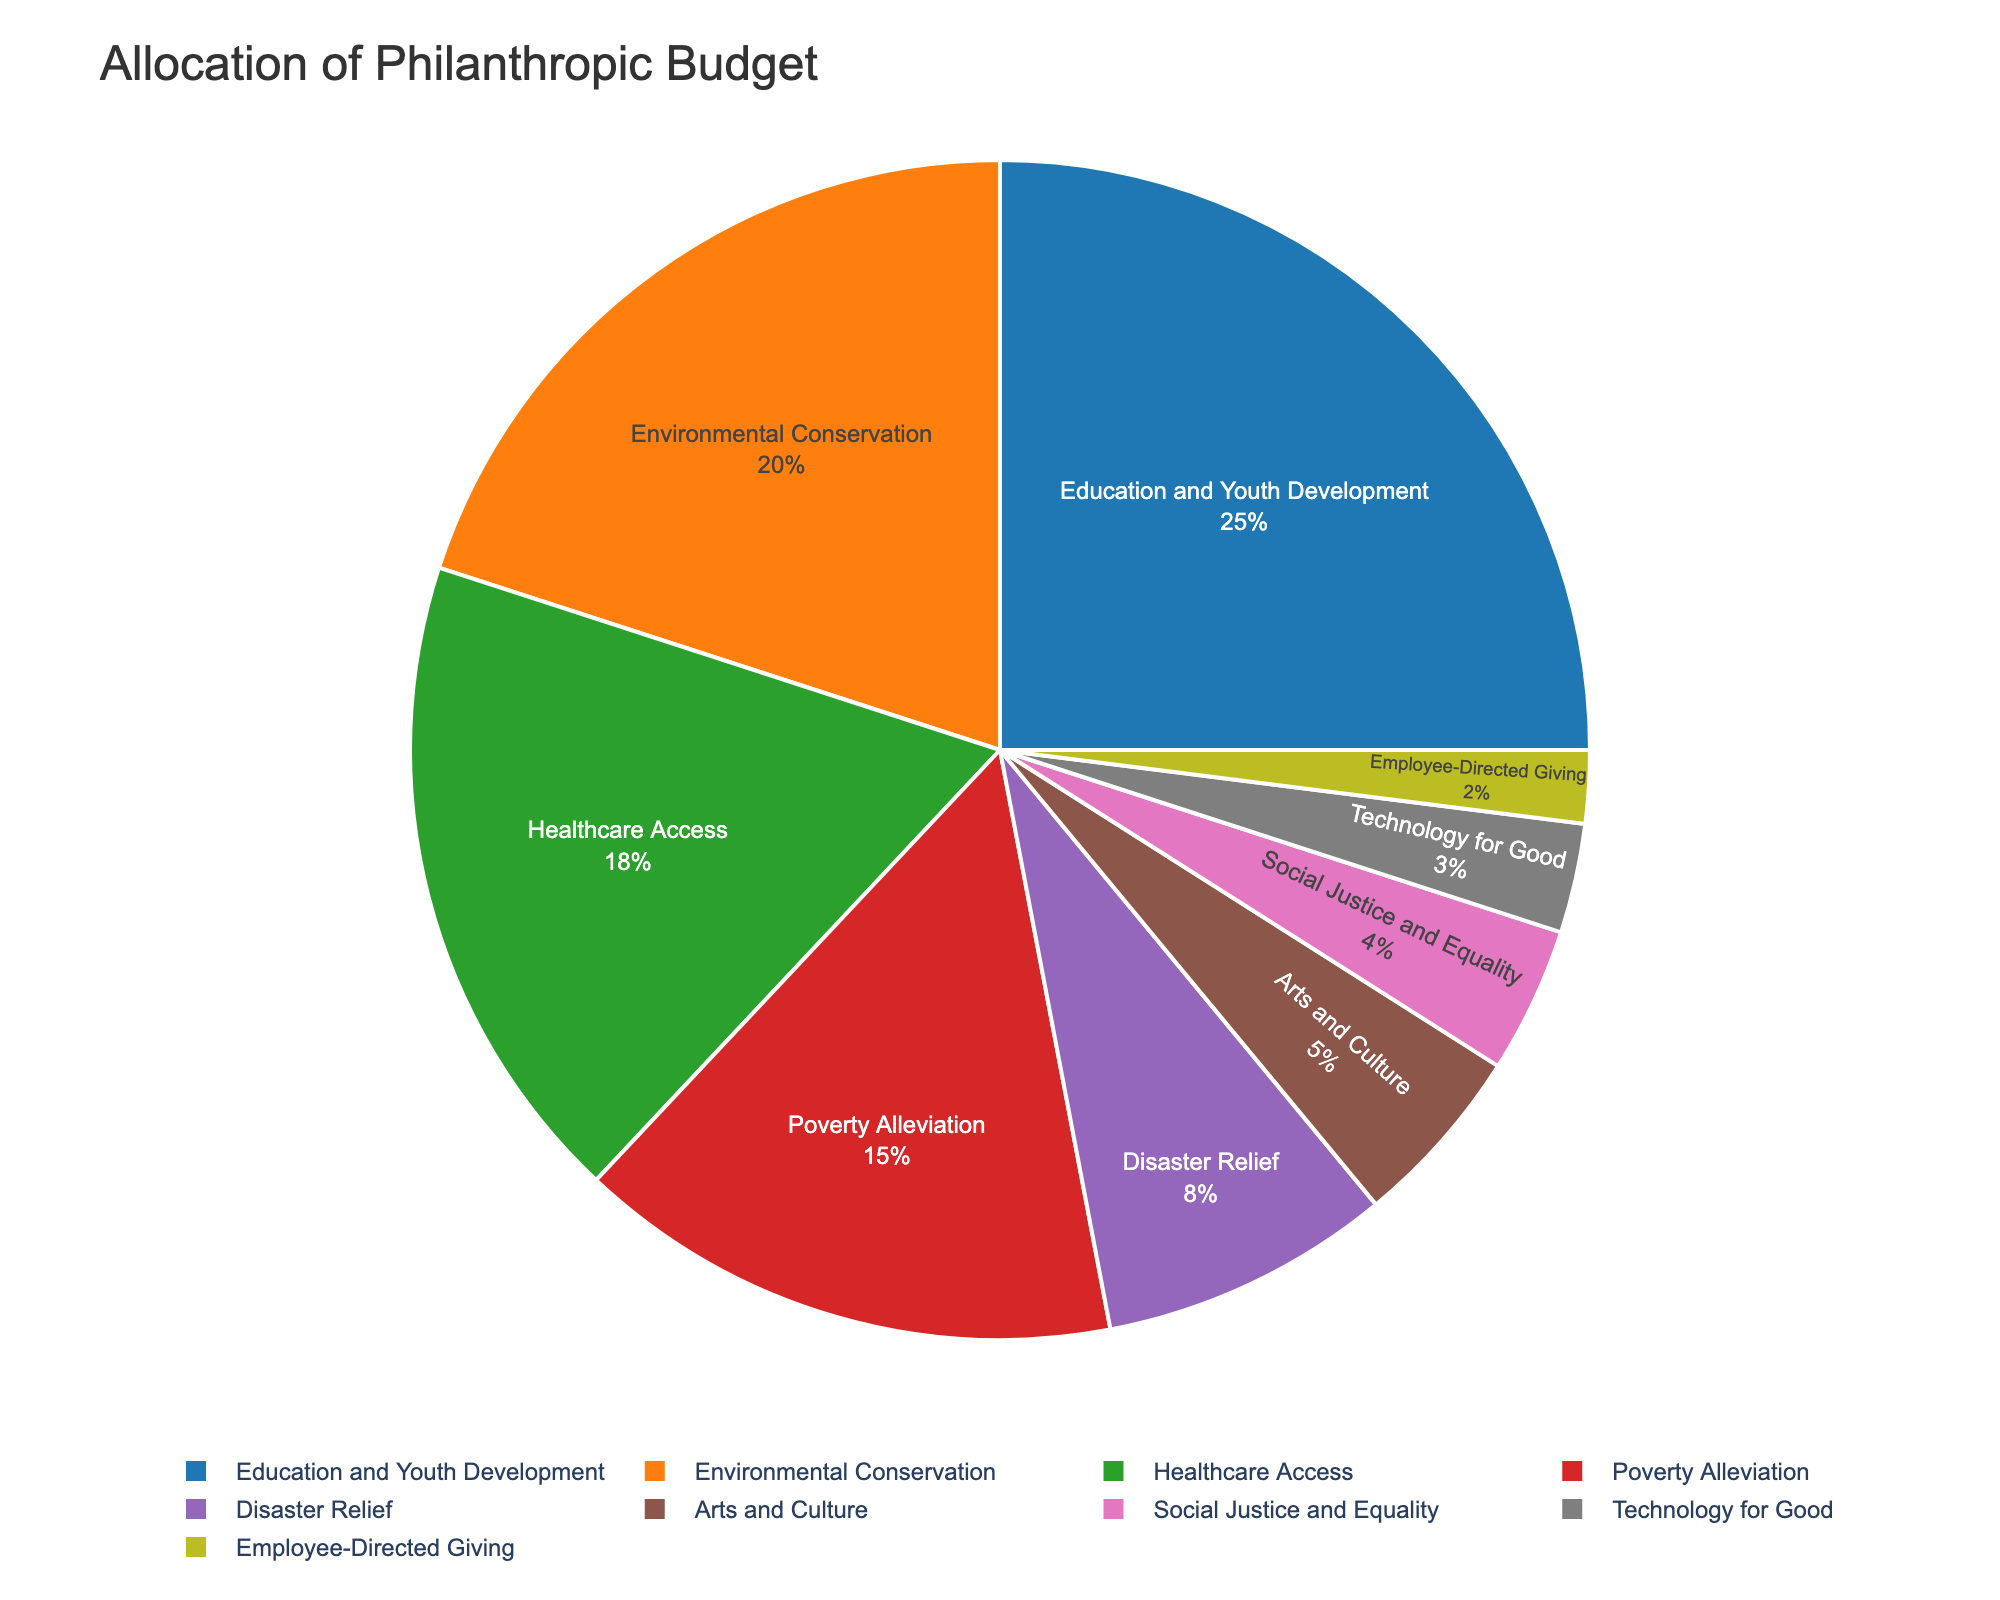What is the cause with the highest allocation in the philanthropic budget? From the pie chart, Education and Youth Development segment covers the largest portion, visibly more significant than any other cause.
Answer: Education and Youth Development What's the combined percentage of the budget allocated to Education and Youth Development and Environmental Conservation? The pie chart shows 25% for Education and Youth Development and 20% for Environmental Conservation. Adding these gives us 25% + 20% = 45%.
Answer: 45% What is the difference in allocation between Healthcare Access and Poverty Alleviation? The pie chart shows 18% for Healthcare Access and 15% for Poverty Alleviation. Subtracting these gives us 18% - 15% = 3%.
Answer: 3% Which cause has the least allocation, and what is its percentage? The smallest segment in the pie chart corresponds to Employee-Directed Giving, which has the lowest percentage.
Answer: Employee-Directed Giving, 2% What is the average percentage allocation for Disaster Relief, Arts and Culture, Social Justice and Equality, and Technology for Good? The chart shows the percentages as 8% for Disaster Relief, 5% for Arts and Culture, 4% for Social Justice and Equality, and 3% for Technology for Good. Adding these gives us (8% + 5% + 4% + 3%) = 20%. Dividing by 4 (since there are four causes) gives us 20% / 4 = 5%.
Answer: 5% Which causes together make up more than 50% of the budget? The pie chart indicates that Education and Youth Development (25%), Environmental Conservation (20%), and Healthcare Access (18%) together sum up to 25% + 20% + 18% = 63%, which is more than half of the total budget.
Answer: Education and Youth Development, Environmental Conservation, Healthcare Access What is the visual cue used to distinguish between different causes in the pie chart? The pie chart uses different colors to represent each cause.
Answer: Different colors How much more is allocated to Disaster Relief compared to Social Justice and Equality? The chart shows 8% for Disaster Relief and 4% for Social Justice and Equality. The difference is 8% - 4% = 4%.
Answer: 4% What is the second least allocated cause in the philanthropic budget? From the chart, the second smallest segment after Employee-Directed Giving (2%) is Technology for Good (3%).
Answer: Technology for Good 